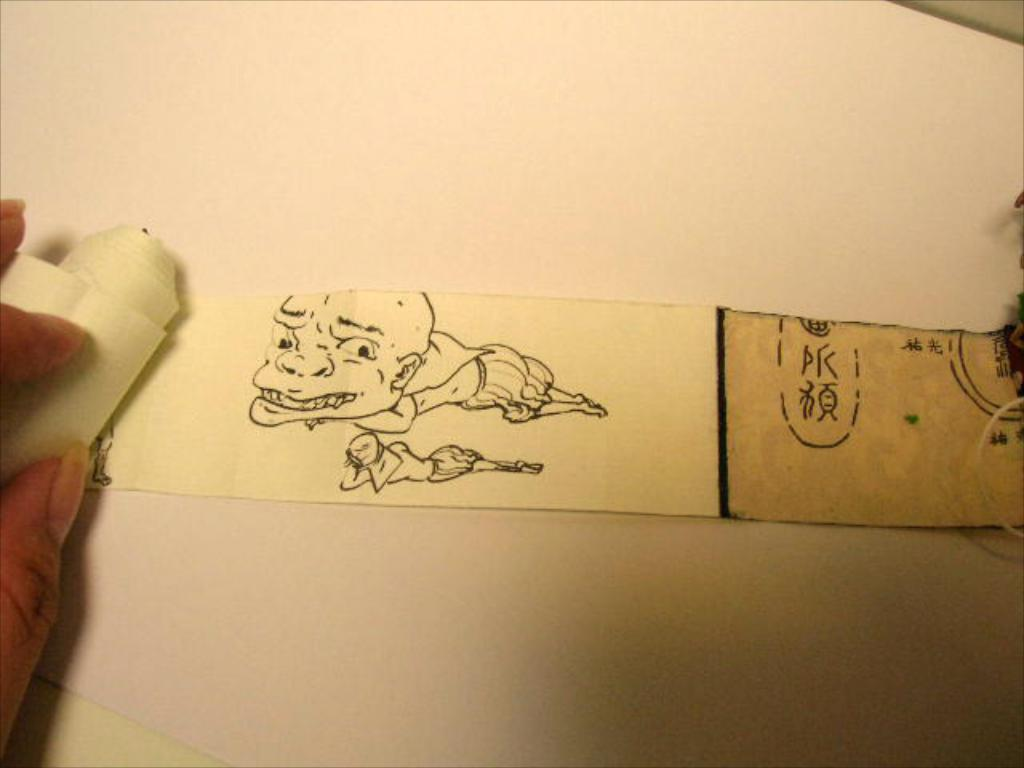What is the main object in the image? There is a white paper in the image. What is depicted on the paper? There is an art on the paper. Where is the human hand located in the image? The human hand is on the left side of the image. What type of garden can be seen in the image? There is no garden present in the image; it features a white paper with art and a human hand. 